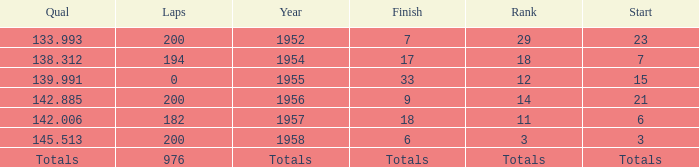What place did Jimmy Reece finish in 1957? 18.0. 